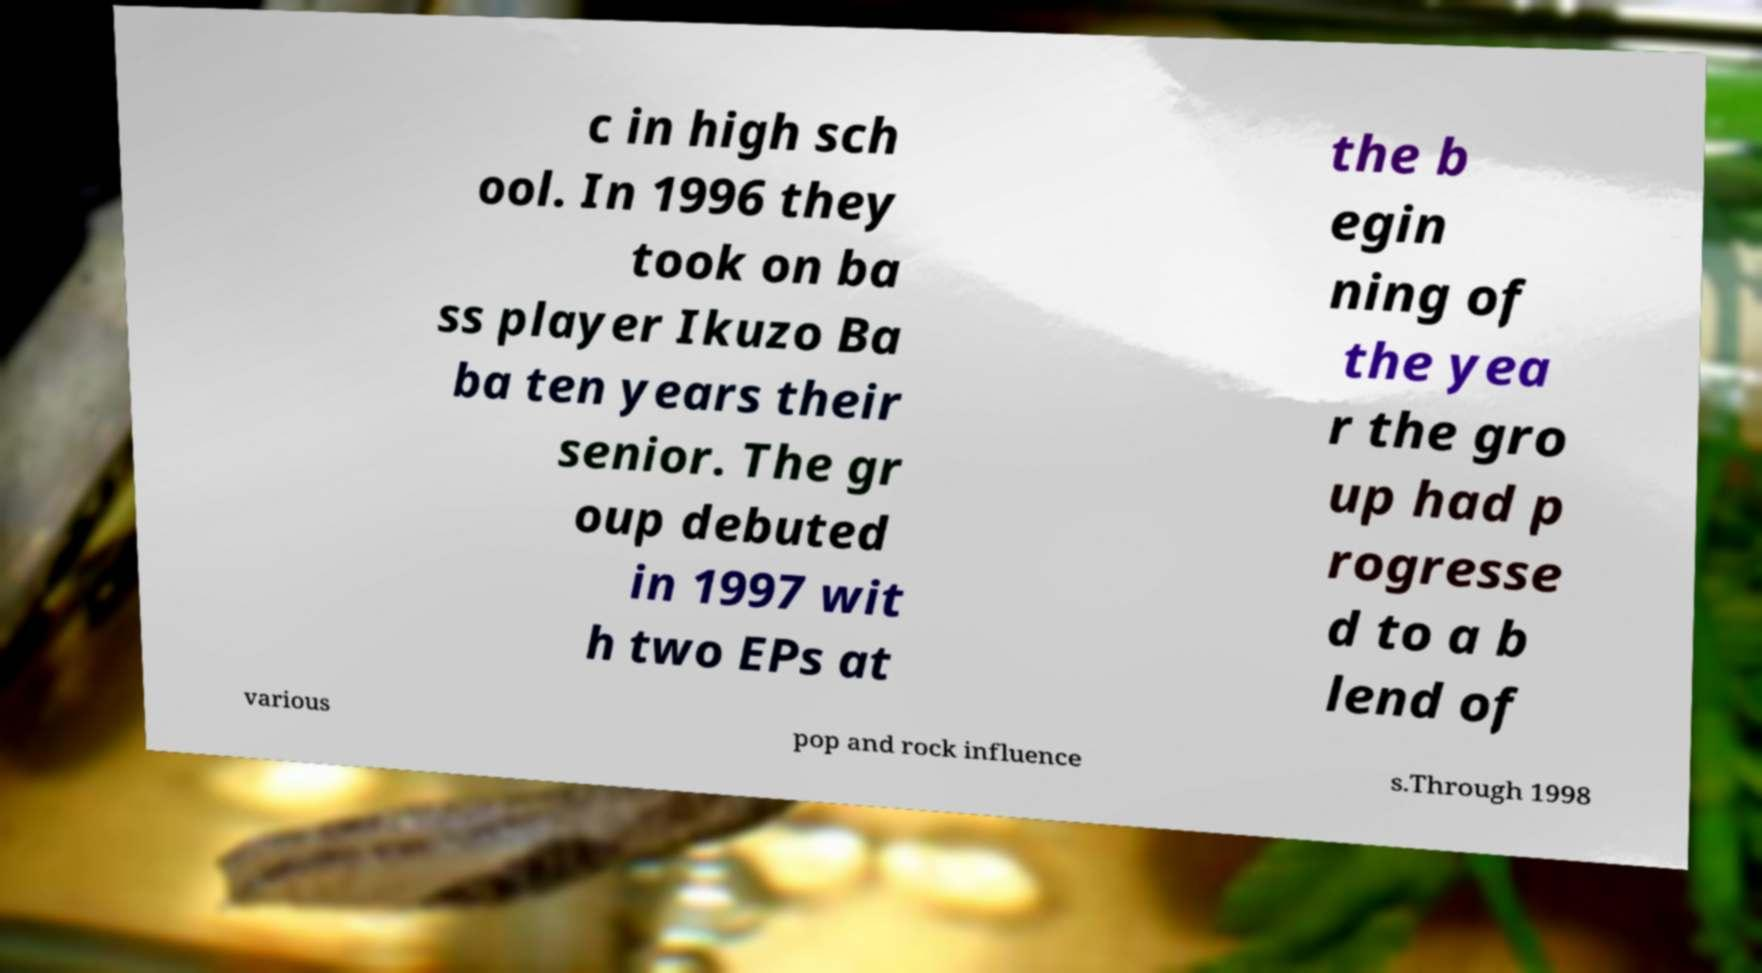Can you read and provide the text displayed in the image?This photo seems to have some interesting text. Can you extract and type it out for me? c in high sch ool. In 1996 they took on ba ss player Ikuzo Ba ba ten years their senior. The gr oup debuted in 1997 wit h two EPs at the b egin ning of the yea r the gro up had p rogresse d to a b lend of various pop and rock influence s.Through 1998 